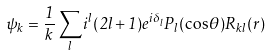Convert formula to latex. <formula><loc_0><loc_0><loc_500><loc_500>\psi _ { k } = \frac { 1 } { k } \sum _ { l } i ^ { l } ( 2 l + 1 ) e ^ { i \delta _ { l } } P _ { l } ( \cos \theta ) R _ { k l } ( r )</formula> 